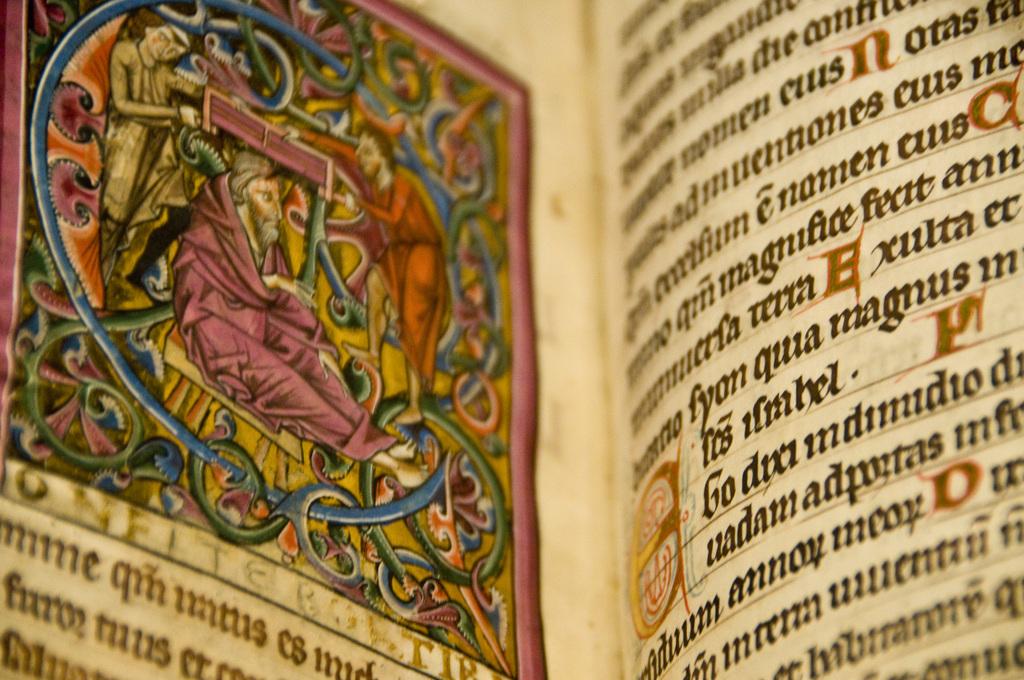What is the word with the large n on the right page?
Offer a very short reply. Notas. 